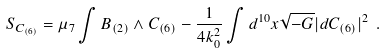<formula> <loc_0><loc_0><loc_500><loc_500>S _ { C _ { ( 6 ) } } = \mu _ { 7 } \int B _ { ( 2 ) } \wedge C _ { ( 6 ) } - \frac { 1 } { 4 k _ { 0 } ^ { 2 } } \int d ^ { 1 0 } x \sqrt { - G } | d C _ { ( 6 ) } | ^ { 2 } \ .</formula> 